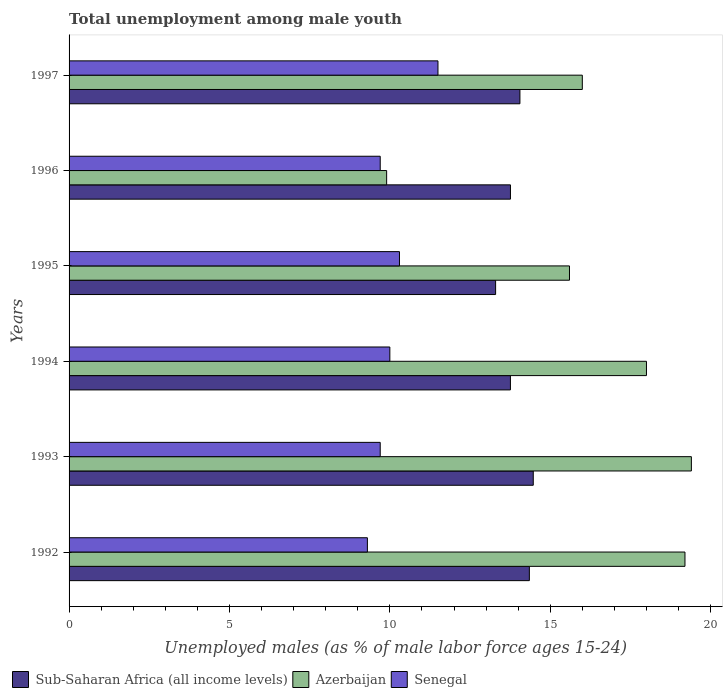How many different coloured bars are there?
Offer a very short reply. 3. How many groups of bars are there?
Provide a short and direct response. 6. Are the number of bars per tick equal to the number of legend labels?
Your answer should be compact. Yes. How many bars are there on the 2nd tick from the top?
Give a very brief answer. 3. What is the percentage of unemployed males in in Sub-Saharan Africa (all income levels) in 1996?
Ensure brevity in your answer.  13.76. Across all years, what is the maximum percentage of unemployed males in in Senegal?
Offer a very short reply. 11.5. Across all years, what is the minimum percentage of unemployed males in in Senegal?
Keep it short and to the point. 9.3. In which year was the percentage of unemployed males in in Senegal maximum?
Give a very brief answer. 1997. What is the total percentage of unemployed males in in Senegal in the graph?
Make the answer very short. 60.5. What is the difference between the percentage of unemployed males in in Azerbaijan in 1992 and that in 1997?
Make the answer very short. 3.2. What is the difference between the percentage of unemployed males in in Senegal in 1994 and the percentage of unemployed males in in Azerbaijan in 1995?
Make the answer very short. -5.6. What is the average percentage of unemployed males in in Azerbaijan per year?
Make the answer very short. 16.35. In the year 1992, what is the difference between the percentage of unemployed males in in Azerbaijan and percentage of unemployed males in in Senegal?
Offer a very short reply. 9.9. In how many years, is the percentage of unemployed males in in Sub-Saharan Africa (all income levels) greater than 14 %?
Your answer should be compact. 3. What is the ratio of the percentage of unemployed males in in Sub-Saharan Africa (all income levels) in 1993 to that in 1994?
Your response must be concise. 1.05. Is the difference between the percentage of unemployed males in in Azerbaijan in 1995 and 1997 greater than the difference between the percentage of unemployed males in in Senegal in 1995 and 1997?
Your answer should be very brief. Yes. What is the difference between the highest and the second highest percentage of unemployed males in in Sub-Saharan Africa (all income levels)?
Ensure brevity in your answer.  0.12. What is the difference between the highest and the lowest percentage of unemployed males in in Sub-Saharan Africa (all income levels)?
Your answer should be compact. 1.17. What does the 3rd bar from the top in 1994 represents?
Ensure brevity in your answer.  Sub-Saharan Africa (all income levels). What does the 3rd bar from the bottom in 1992 represents?
Offer a very short reply. Senegal. Is it the case that in every year, the sum of the percentage of unemployed males in in Senegal and percentage of unemployed males in in Azerbaijan is greater than the percentage of unemployed males in in Sub-Saharan Africa (all income levels)?
Keep it short and to the point. Yes. How many bars are there?
Give a very brief answer. 18. How many years are there in the graph?
Keep it short and to the point. 6. What is the difference between two consecutive major ticks on the X-axis?
Your answer should be compact. 5. Where does the legend appear in the graph?
Provide a short and direct response. Bottom left. How many legend labels are there?
Give a very brief answer. 3. What is the title of the graph?
Give a very brief answer. Total unemployment among male youth. What is the label or title of the X-axis?
Your answer should be compact. Unemployed males (as % of male labor force ages 15-24). What is the Unemployed males (as % of male labor force ages 15-24) of Sub-Saharan Africa (all income levels) in 1992?
Make the answer very short. 14.35. What is the Unemployed males (as % of male labor force ages 15-24) in Azerbaijan in 1992?
Offer a terse response. 19.2. What is the Unemployed males (as % of male labor force ages 15-24) in Senegal in 1992?
Make the answer very short. 9.3. What is the Unemployed males (as % of male labor force ages 15-24) of Sub-Saharan Africa (all income levels) in 1993?
Your answer should be compact. 14.47. What is the Unemployed males (as % of male labor force ages 15-24) in Azerbaijan in 1993?
Provide a succinct answer. 19.4. What is the Unemployed males (as % of male labor force ages 15-24) in Senegal in 1993?
Offer a terse response. 9.7. What is the Unemployed males (as % of male labor force ages 15-24) in Sub-Saharan Africa (all income levels) in 1994?
Your answer should be compact. 13.76. What is the Unemployed males (as % of male labor force ages 15-24) in Azerbaijan in 1994?
Offer a terse response. 18. What is the Unemployed males (as % of male labor force ages 15-24) in Sub-Saharan Africa (all income levels) in 1995?
Give a very brief answer. 13.3. What is the Unemployed males (as % of male labor force ages 15-24) of Azerbaijan in 1995?
Your response must be concise. 15.6. What is the Unemployed males (as % of male labor force ages 15-24) of Senegal in 1995?
Offer a terse response. 10.3. What is the Unemployed males (as % of male labor force ages 15-24) of Sub-Saharan Africa (all income levels) in 1996?
Give a very brief answer. 13.76. What is the Unemployed males (as % of male labor force ages 15-24) in Azerbaijan in 1996?
Give a very brief answer. 9.9. What is the Unemployed males (as % of male labor force ages 15-24) of Senegal in 1996?
Keep it short and to the point. 9.7. What is the Unemployed males (as % of male labor force ages 15-24) in Sub-Saharan Africa (all income levels) in 1997?
Offer a terse response. 14.06. What is the Unemployed males (as % of male labor force ages 15-24) of Senegal in 1997?
Provide a succinct answer. 11.5. Across all years, what is the maximum Unemployed males (as % of male labor force ages 15-24) in Sub-Saharan Africa (all income levels)?
Your answer should be very brief. 14.47. Across all years, what is the maximum Unemployed males (as % of male labor force ages 15-24) of Azerbaijan?
Your response must be concise. 19.4. Across all years, what is the minimum Unemployed males (as % of male labor force ages 15-24) in Sub-Saharan Africa (all income levels)?
Make the answer very short. 13.3. Across all years, what is the minimum Unemployed males (as % of male labor force ages 15-24) in Azerbaijan?
Your answer should be compact. 9.9. Across all years, what is the minimum Unemployed males (as % of male labor force ages 15-24) of Senegal?
Give a very brief answer. 9.3. What is the total Unemployed males (as % of male labor force ages 15-24) in Sub-Saharan Africa (all income levels) in the graph?
Your answer should be very brief. 83.69. What is the total Unemployed males (as % of male labor force ages 15-24) in Azerbaijan in the graph?
Provide a succinct answer. 98.1. What is the total Unemployed males (as % of male labor force ages 15-24) of Senegal in the graph?
Give a very brief answer. 60.5. What is the difference between the Unemployed males (as % of male labor force ages 15-24) in Sub-Saharan Africa (all income levels) in 1992 and that in 1993?
Provide a short and direct response. -0.12. What is the difference between the Unemployed males (as % of male labor force ages 15-24) of Sub-Saharan Africa (all income levels) in 1992 and that in 1994?
Ensure brevity in your answer.  0.59. What is the difference between the Unemployed males (as % of male labor force ages 15-24) of Senegal in 1992 and that in 1994?
Offer a terse response. -0.7. What is the difference between the Unemployed males (as % of male labor force ages 15-24) in Sub-Saharan Africa (all income levels) in 1992 and that in 1995?
Your response must be concise. 1.05. What is the difference between the Unemployed males (as % of male labor force ages 15-24) of Sub-Saharan Africa (all income levels) in 1992 and that in 1996?
Make the answer very short. 0.59. What is the difference between the Unemployed males (as % of male labor force ages 15-24) in Senegal in 1992 and that in 1996?
Provide a short and direct response. -0.4. What is the difference between the Unemployed males (as % of male labor force ages 15-24) in Sub-Saharan Africa (all income levels) in 1992 and that in 1997?
Keep it short and to the point. 0.29. What is the difference between the Unemployed males (as % of male labor force ages 15-24) in Senegal in 1992 and that in 1997?
Your response must be concise. -2.2. What is the difference between the Unemployed males (as % of male labor force ages 15-24) of Sub-Saharan Africa (all income levels) in 1993 and that in 1994?
Your response must be concise. 0.71. What is the difference between the Unemployed males (as % of male labor force ages 15-24) in Azerbaijan in 1993 and that in 1994?
Your response must be concise. 1.4. What is the difference between the Unemployed males (as % of male labor force ages 15-24) of Senegal in 1993 and that in 1994?
Provide a succinct answer. -0.3. What is the difference between the Unemployed males (as % of male labor force ages 15-24) of Sub-Saharan Africa (all income levels) in 1993 and that in 1995?
Ensure brevity in your answer.  1.17. What is the difference between the Unemployed males (as % of male labor force ages 15-24) in Sub-Saharan Africa (all income levels) in 1993 and that in 1996?
Your response must be concise. 0.71. What is the difference between the Unemployed males (as % of male labor force ages 15-24) in Azerbaijan in 1993 and that in 1996?
Your answer should be very brief. 9.5. What is the difference between the Unemployed males (as % of male labor force ages 15-24) of Senegal in 1993 and that in 1996?
Keep it short and to the point. 0. What is the difference between the Unemployed males (as % of male labor force ages 15-24) in Sub-Saharan Africa (all income levels) in 1993 and that in 1997?
Provide a short and direct response. 0.42. What is the difference between the Unemployed males (as % of male labor force ages 15-24) in Sub-Saharan Africa (all income levels) in 1994 and that in 1995?
Give a very brief answer. 0.46. What is the difference between the Unemployed males (as % of male labor force ages 15-24) in Azerbaijan in 1994 and that in 1995?
Make the answer very short. 2.4. What is the difference between the Unemployed males (as % of male labor force ages 15-24) of Sub-Saharan Africa (all income levels) in 1994 and that in 1996?
Ensure brevity in your answer.  -0. What is the difference between the Unemployed males (as % of male labor force ages 15-24) of Senegal in 1994 and that in 1996?
Your answer should be very brief. 0.3. What is the difference between the Unemployed males (as % of male labor force ages 15-24) of Sub-Saharan Africa (all income levels) in 1994 and that in 1997?
Offer a very short reply. -0.3. What is the difference between the Unemployed males (as % of male labor force ages 15-24) in Senegal in 1994 and that in 1997?
Provide a succinct answer. -1.5. What is the difference between the Unemployed males (as % of male labor force ages 15-24) of Sub-Saharan Africa (all income levels) in 1995 and that in 1996?
Provide a succinct answer. -0.46. What is the difference between the Unemployed males (as % of male labor force ages 15-24) in Sub-Saharan Africa (all income levels) in 1995 and that in 1997?
Your answer should be compact. -0.76. What is the difference between the Unemployed males (as % of male labor force ages 15-24) in Sub-Saharan Africa (all income levels) in 1996 and that in 1997?
Make the answer very short. -0.3. What is the difference between the Unemployed males (as % of male labor force ages 15-24) in Senegal in 1996 and that in 1997?
Your answer should be compact. -1.8. What is the difference between the Unemployed males (as % of male labor force ages 15-24) of Sub-Saharan Africa (all income levels) in 1992 and the Unemployed males (as % of male labor force ages 15-24) of Azerbaijan in 1993?
Keep it short and to the point. -5.05. What is the difference between the Unemployed males (as % of male labor force ages 15-24) of Sub-Saharan Africa (all income levels) in 1992 and the Unemployed males (as % of male labor force ages 15-24) of Senegal in 1993?
Your response must be concise. 4.65. What is the difference between the Unemployed males (as % of male labor force ages 15-24) in Sub-Saharan Africa (all income levels) in 1992 and the Unemployed males (as % of male labor force ages 15-24) in Azerbaijan in 1994?
Your answer should be compact. -3.65. What is the difference between the Unemployed males (as % of male labor force ages 15-24) in Sub-Saharan Africa (all income levels) in 1992 and the Unemployed males (as % of male labor force ages 15-24) in Senegal in 1994?
Ensure brevity in your answer.  4.35. What is the difference between the Unemployed males (as % of male labor force ages 15-24) in Azerbaijan in 1992 and the Unemployed males (as % of male labor force ages 15-24) in Senegal in 1994?
Provide a succinct answer. 9.2. What is the difference between the Unemployed males (as % of male labor force ages 15-24) in Sub-Saharan Africa (all income levels) in 1992 and the Unemployed males (as % of male labor force ages 15-24) in Azerbaijan in 1995?
Offer a terse response. -1.25. What is the difference between the Unemployed males (as % of male labor force ages 15-24) of Sub-Saharan Africa (all income levels) in 1992 and the Unemployed males (as % of male labor force ages 15-24) of Senegal in 1995?
Give a very brief answer. 4.05. What is the difference between the Unemployed males (as % of male labor force ages 15-24) of Sub-Saharan Africa (all income levels) in 1992 and the Unemployed males (as % of male labor force ages 15-24) of Azerbaijan in 1996?
Offer a terse response. 4.45. What is the difference between the Unemployed males (as % of male labor force ages 15-24) in Sub-Saharan Africa (all income levels) in 1992 and the Unemployed males (as % of male labor force ages 15-24) in Senegal in 1996?
Provide a short and direct response. 4.65. What is the difference between the Unemployed males (as % of male labor force ages 15-24) of Azerbaijan in 1992 and the Unemployed males (as % of male labor force ages 15-24) of Senegal in 1996?
Make the answer very short. 9.5. What is the difference between the Unemployed males (as % of male labor force ages 15-24) of Sub-Saharan Africa (all income levels) in 1992 and the Unemployed males (as % of male labor force ages 15-24) of Azerbaijan in 1997?
Your response must be concise. -1.65. What is the difference between the Unemployed males (as % of male labor force ages 15-24) in Sub-Saharan Africa (all income levels) in 1992 and the Unemployed males (as % of male labor force ages 15-24) in Senegal in 1997?
Offer a very short reply. 2.85. What is the difference between the Unemployed males (as % of male labor force ages 15-24) of Azerbaijan in 1992 and the Unemployed males (as % of male labor force ages 15-24) of Senegal in 1997?
Provide a short and direct response. 7.7. What is the difference between the Unemployed males (as % of male labor force ages 15-24) in Sub-Saharan Africa (all income levels) in 1993 and the Unemployed males (as % of male labor force ages 15-24) in Azerbaijan in 1994?
Ensure brevity in your answer.  -3.53. What is the difference between the Unemployed males (as % of male labor force ages 15-24) in Sub-Saharan Africa (all income levels) in 1993 and the Unemployed males (as % of male labor force ages 15-24) in Senegal in 1994?
Provide a short and direct response. 4.47. What is the difference between the Unemployed males (as % of male labor force ages 15-24) in Azerbaijan in 1993 and the Unemployed males (as % of male labor force ages 15-24) in Senegal in 1994?
Keep it short and to the point. 9.4. What is the difference between the Unemployed males (as % of male labor force ages 15-24) of Sub-Saharan Africa (all income levels) in 1993 and the Unemployed males (as % of male labor force ages 15-24) of Azerbaijan in 1995?
Your answer should be very brief. -1.13. What is the difference between the Unemployed males (as % of male labor force ages 15-24) of Sub-Saharan Africa (all income levels) in 1993 and the Unemployed males (as % of male labor force ages 15-24) of Senegal in 1995?
Your answer should be compact. 4.17. What is the difference between the Unemployed males (as % of male labor force ages 15-24) of Azerbaijan in 1993 and the Unemployed males (as % of male labor force ages 15-24) of Senegal in 1995?
Provide a succinct answer. 9.1. What is the difference between the Unemployed males (as % of male labor force ages 15-24) in Sub-Saharan Africa (all income levels) in 1993 and the Unemployed males (as % of male labor force ages 15-24) in Azerbaijan in 1996?
Offer a terse response. 4.57. What is the difference between the Unemployed males (as % of male labor force ages 15-24) in Sub-Saharan Africa (all income levels) in 1993 and the Unemployed males (as % of male labor force ages 15-24) in Senegal in 1996?
Provide a short and direct response. 4.77. What is the difference between the Unemployed males (as % of male labor force ages 15-24) of Azerbaijan in 1993 and the Unemployed males (as % of male labor force ages 15-24) of Senegal in 1996?
Keep it short and to the point. 9.7. What is the difference between the Unemployed males (as % of male labor force ages 15-24) of Sub-Saharan Africa (all income levels) in 1993 and the Unemployed males (as % of male labor force ages 15-24) of Azerbaijan in 1997?
Give a very brief answer. -1.53. What is the difference between the Unemployed males (as % of male labor force ages 15-24) in Sub-Saharan Africa (all income levels) in 1993 and the Unemployed males (as % of male labor force ages 15-24) in Senegal in 1997?
Offer a terse response. 2.97. What is the difference between the Unemployed males (as % of male labor force ages 15-24) of Sub-Saharan Africa (all income levels) in 1994 and the Unemployed males (as % of male labor force ages 15-24) of Azerbaijan in 1995?
Offer a terse response. -1.84. What is the difference between the Unemployed males (as % of male labor force ages 15-24) in Sub-Saharan Africa (all income levels) in 1994 and the Unemployed males (as % of male labor force ages 15-24) in Senegal in 1995?
Provide a succinct answer. 3.46. What is the difference between the Unemployed males (as % of male labor force ages 15-24) of Azerbaijan in 1994 and the Unemployed males (as % of male labor force ages 15-24) of Senegal in 1995?
Offer a terse response. 7.7. What is the difference between the Unemployed males (as % of male labor force ages 15-24) in Sub-Saharan Africa (all income levels) in 1994 and the Unemployed males (as % of male labor force ages 15-24) in Azerbaijan in 1996?
Provide a short and direct response. 3.86. What is the difference between the Unemployed males (as % of male labor force ages 15-24) in Sub-Saharan Africa (all income levels) in 1994 and the Unemployed males (as % of male labor force ages 15-24) in Senegal in 1996?
Your answer should be very brief. 4.06. What is the difference between the Unemployed males (as % of male labor force ages 15-24) in Sub-Saharan Africa (all income levels) in 1994 and the Unemployed males (as % of male labor force ages 15-24) in Azerbaijan in 1997?
Ensure brevity in your answer.  -2.24. What is the difference between the Unemployed males (as % of male labor force ages 15-24) of Sub-Saharan Africa (all income levels) in 1994 and the Unemployed males (as % of male labor force ages 15-24) of Senegal in 1997?
Keep it short and to the point. 2.26. What is the difference between the Unemployed males (as % of male labor force ages 15-24) of Azerbaijan in 1994 and the Unemployed males (as % of male labor force ages 15-24) of Senegal in 1997?
Your answer should be very brief. 6.5. What is the difference between the Unemployed males (as % of male labor force ages 15-24) in Sub-Saharan Africa (all income levels) in 1995 and the Unemployed males (as % of male labor force ages 15-24) in Azerbaijan in 1996?
Provide a short and direct response. 3.4. What is the difference between the Unemployed males (as % of male labor force ages 15-24) of Sub-Saharan Africa (all income levels) in 1995 and the Unemployed males (as % of male labor force ages 15-24) of Senegal in 1996?
Your response must be concise. 3.6. What is the difference between the Unemployed males (as % of male labor force ages 15-24) of Azerbaijan in 1995 and the Unemployed males (as % of male labor force ages 15-24) of Senegal in 1996?
Keep it short and to the point. 5.9. What is the difference between the Unemployed males (as % of male labor force ages 15-24) of Sub-Saharan Africa (all income levels) in 1995 and the Unemployed males (as % of male labor force ages 15-24) of Azerbaijan in 1997?
Your answer should be very brief. -2.7. What is the difference between the Unemployed males (as % of male labor force ages 15-24) of Sub-Saharan Africa (all income levels) in 1995 and the Unemployed males (as % of male labor force ages 15-24) of Senegal in 1997?
Provide a succinct answer. 1.8. What is the difference between the Unemployed males (as % of male labor force ages 15-24) in Azerbaijan in 1995 and the Unemployed males (as % of male labor force ages 15-24) in Senegal in 1997?
Give a very brief answer. 4.1. What is the difference between the Unemployed males (as % of male labor force ages 15-24) in Sub-Saharan Africa (all income levels) in 1996 and the Unemployed males (as % of male labor force ages 15-24) in Azerbaijan in 1997?
Your response must be concise. -2.24. What is the difference between the Unemployed males (as % of male labor force ages 15-24) of Sub-Saharan Africa (all income levels) in 1996 and the Unemployed males (as % of male labor force ages 15-24) of Senegal in 1997?
Make the answer very short. 2.26. What is the difference between the Unemployed males (as % of male labor force ages 15-24) of Azerbaijan in 1996 and the Unemployed males (as % of male labor force ages 15-24) of Senegal in 1997?
Offer a very short reply. -1.6. What is the average Unemployed males (as % of male labor force ages 15-24) in Sub-Saharan Africa (all income levels) per year?
Provide a succinct answer. 13.95. What is the average Unemployed males (as % of male labor force ages 15-24) of Azerbaijan per year?
Offer a very short reply. 16.35. What is the average Unemployed males (as % of male labor force ages 15-24) of Senegal per year?
Provide a succinct answer. 10.08. In the year 1992, what is the difference between the Unemployed males (as % of male labor force ages 15-24) in Sub-Saharan Africa (all income levels) and Unemployed males (as % of male labor force ages 15-24) in Azerbaijan?
Make the answer very short. -4.85. In the year 1992, what is the difference between the Unemployed males (as % of male labor force ages 15-24) in Sub-Saharan Africa (all income levels) and Unemployed males (as % of male labor force ages 15-24) in Senegal?
Ensure brevity in your answer.  5.05. In the year 1993, what is the difference between the Unemployed males (as % of male labor force ages 15-24) of Sub-Saharan Africa (all income levels) and Unemployed males (as % of male labor force ages 15-24) of Azerbaijan?
Give a very brief answer. -4.93. In the year 1993, what is the difference between the Unemployed males (as % of male labor force ages 15-24) of Sub-Saharan Africa (all income levels) and Unemployed males (as % of male labor force ages 15-24) of Senegal?
Make the answer very short. 4.77. In the year 1993, what is the difference between the Unemployed males (as % of male labor force ages 15-24) in Azerbaijan and Unemployed males (as % of male labor force ages 15-24) in Senegal?
Your answer should be very brief. 9.7. In the year 1994, what is the difference between the Unemployed males (as % of male labor force ages 15-24) of Sub-Saharan Africa (all income levels) and Unemployed males (as % of male labor force ages 15-24) of Azerbaijan?
Your response must be concise. -4.24. In the year 1994, what is the difference between the Unemployed males (as % of male labor force ages 15-24) in Sub-Saharan Africa (all income levels) and Unemployed males (as % of male labor force ages 15-24) in Senegal?
Keep it short and to the point. 3.76. In the year 1995, what is the difference between the Unemployed males (as % of male labor force ages 15-24) of Sub-Saharan Africa (all income levels) and Unemployed males (as % of male labor force ages 15-24) of Azerbaijan?
Your answer should be very brief. -2.3. In the year 1995, what is the difference between the Unemployed males (as % of male labor force ages 15-24) in Sub-Saharan Africa (all income levels) and Unemployed males (as % of male labor force ages 15-24) in Senegal?
Offer a terse response. 3. In the year 1996, what is the difference between the Unemployed males (as % of male labor force ages 15-24) in Sub-Saharan Africa (all income levels) and Unemployed males (as % of male labor force ages 15-24) in Azerbaijan?
Your answer should be very brief. 3.86. In the year 1996, what is the difference between the Unemployed males (as % of male labor force ages 15-24) in Sub-Saharan Africa (all income levels) and Unemployed males (as % of male labor force ages 15-24) in Senegal?
Offer a very short reply. 4.06. In the year 1997, what is the difference between the Unemployed males (as % of male labor force ages 15-24) in Sub-Saharan Africa (all income levels) and Unemployed males (as % of male labor force ages 15-24) in Azerbaijan?
Ensure brevity in your answer.  -1.94. In the year 1997, what is the difference between the Unemployed males (as % of male labor force ages 15-24) in Sub-Saharan Africa (all income levels) and Unemployed males (as % of male labor force ages 15-24) in Senegal?
Your answer should be compact. 2.56. What is the ratio of the Unemployed males (as % of male labor force ages 15-24) of Sub-Saharan Africa (all income levels) in 1992 to that in 1993?
Give a very brief answer. 0.99. What is the ratio of the Unemployed males (as % of male labor force ages 15-24) of Senegal in 1992 to that in 1993?
Provide a succinct answer. 0.96. What is the ratio of the Unemployed males (as % of male labor force ages 15-24) in Sub-Saharan Africa (all income levels) in 1992 to that in 1994?
Give a very brief answer. 1.04. What is the ratio of the Unemployed males (as % of male labor force ages 15-24) of Azerbaijan in 1992 to that in 1994?
Your answer should be compact. 1.07. What is the ratio of the Unemployed males (as % of male labor force ages 15-24) of Senegal in 1992 to that in 1994?
Offer a terse response. 0.93. What is the ratio of the Unemployed males (as % of male labor force ages 15-24) of Sub-Saharan Africa (all income levels) in 1992 to that in 1995?
Keep it short and to the point. 1.08. What is the ratio of the Unemployed males (as % of male labor force ages 15-24) of Azerbaijan in 1992 to that in 1995?
Ensure brevity in your answer.  1.23. What is the ratio of the Unemployed males (as % of male labor force ages 15-24) in Senegal in 1992 to that in 1995?
Your response must be concise. 0.9. What is the ratio of the Unemployed males (as % of male labor force ages 15-24) of Sub-Saharan Africa (all income levels) in 1992 to that in 1996?
Keep it short and to the point. 1.04. What is the ratio of the Unemployed males (as % of male labor force ages 15-24) of Azerbaijan in 1992 to that in 1996?
Offer a terse response. 1.94. What is the ratio of the Unemployed males (as % of male labor force ages 15-24) of Senegal in 1992 to that in 1996?
Offer a very short reply. 0.96. What is the ratio of the Unemployed males (as % of male labor force ages 15-24) of Sub-Saharan Africa (all income levels) in 1992 to that in 1997?
Ensure brevity in your answer.  1.02. What is the ratio of the Unemployed males (as % of male labor force ages 15-24) of Senegal in 1992 to that in 1997?
Your answer should be very brief. 0.81. What is the ratio of the Unemployed males (as % of male labor force ages 15-24) in Sub-Saharan Africa (all income levels) in 1993 to that in 1994?
Provide a short and direct response. 1.05. What is the ratio of the Unemployed males (as % of male labor force ages 15-24) in Azerbaijan in 1993 to that in 1994?
Make the answer very short. 1.08. What is the ratio of the Unemployed males (as % of male labor force ages 15-24) in Sub-Saharan Africa (all income levels) in 1993 to that in 1995?
Offer a very short reply. 1.09. What is the ratio of the Unemployed males (as % of male labor force ages 15-24) in Azerbaijan in 1993 to that in 1995?
Offer a very short reply. 1.24. What is the ratio of the Unemployed males (as % of male labor force ages 15-24) of Senegal in 1993 to that in 1995?
Ensure brevity in your answer.  0.94. What is the ratio of the Unemployed males (as % of male labor force ages 15-24) of Sub-Saharan Africa (all income levels) in 1993 to that in 1996?
Give a very brief answer. 1.05. What is the ratio of the Unemployed males (as % of male labor force ages 15-24) in Azerbaijan in 1993 to that in 1996?
Provide a succinct answer. 1.96. What is the ratio of the Unemployed males (as % of male labor force ages 15-24) in Sub-Saharan Africa (all income levels) in 1993 to that in 1997?
Offer a terse response. 1.03. What is the ratio of the Unemployed males (as % of male labor force ages 15-24) in Azerbaijan in 1993 to that in 1997?
Offer a very short reply. 1.21. What is the ratio of the Unemployed males (as % of male labor force ages 15-24) in Senegal in 1993 to that in 1997?
Your answer should be very brief. 0.84. What is the ratio of the Unemployed males (as % of male labor force ages 15-24) in Sub-Saharan Africa (all income levels) in 1994 to that in 1995?
Ensure brevity in your answer.  1.03. What is the ratio of the Unemployed males (as % of male labor force ages 15-24) in Azerbaijan in 1994 to that in 1995?
Offer a terse response. 1.15. What is the ratio of the Unemployed males (as % of male labor force ages 15-24) of Senegal in 1994 to that in 1995?
Make the answer very short. 0.97. What is the ratio of the Unemployed males (as % of male labor force ages 15-24) of Sub-Saharan Africa (all income levels) in 1994 to that in 1996?
Give a very brief answer. 1. What is the ratio of the Unemployed males (as % of male labor force ages 15-24) in Azerbaijan in 1994 to that in 1996?
Your answer should be compact. 1.82. What is the ratio of the Unemployed males (as % of male labor force ages 15-24) in Senegal in 1994 to that in 1996?
Provide a succinct answer. 1.03. What is the ratio of the Unemployed males (as % of male labor force ages 15-24) in Sub-Saharan Africa (all income levels) in 1994 to that in 1997?
Your answer should be very brief. 0.98. What is the ratio of the Unemployed males (as % of male labor force ages 15-24) of Senegal in 1994 to that in 1997?
Your answer should be very brief. 0.87. What is the ratio of the Unemployed males (as % of male labor force ages 15-24) of Sub-Saharan Africa (all income levels) in 1995 to that in 1996?
Provide a succinct answer. 0.97. What is the ratio of the Unemployed males (as % of male labor force ages 15-24) of Azerbaijan in 1995 to that in 1996?
Make the answer very short. 1.58. What is the ratio of the Unemployed males (as % of male labor force ages 15-24) of Senegal in 1995 to that in 1996?
Make the answer very short. 1.06. What is the ratio of the Unemployed males (as % of male labor force ages 15-24) of Sub-Saharan Africa (all income levels) in 1995 to that in 1997?
Offer a very short reply. 0.95. What is the ratio of the Unemployed males (as % of male labor force ages 15-24) in Senegal in 1995 to that in 1997?
Offer a very short reply. 0.9. What is the ratio of the Unemployed males (as % of male labor force ages 15-24) in Sub-Saharan Africa (all income levels) in 1996 to that in 1997?
Keep it short and to the point. 0.98. What is the ratio of the Unemployed males (as % of male labor force ages 15-24) in Azerbaijan in 1996 to that in 1997?
Your answer should be compact. 0.62. What is the ratio of the Unemployed males (as % of male labor force ages 15-24) in Senegal in 1996 to that in 1997?
Offer a terse response. 0.84. What is the difference between the highest and the second highest Unemployed males (as % of male labor force ages 15-24) in Sub-Saharan Africa (all income levels)?
Your response must be concise. 0.12. What is the difference between the highest and the second highest Unemployed males (as % of male labor force ages 15-24) in Azerbaijan?
Your response must be concise. 0.2. What is the difference between the highest and the lowest Unemployed males (as % of male labor force ages 15-24) of Sub-Saharan Africa (all income levels)?
Offer a terse response. 1.17. What is the difference between the highest and the lowest Unemployed males (as % of male labor force ages 15-24) in Azerbaijan?
Make the answer very short. 9.5. What is the difference between the highest and the lowest Unemployed males (as % of male labor force ages 15-24) in Senegal?
Make the answer very short. 2.2. 